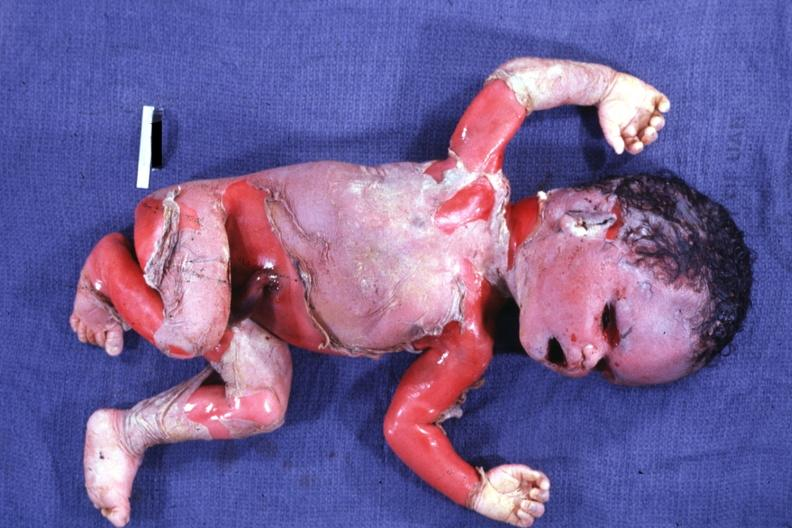s mesothelioma present?
Answer the question using a single word or phrase. No 